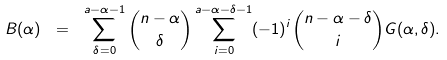<formula> <loc_0><loc_0><loc_500><loc_500>B ( \alpha ) \ = \ \sum _ { \delta = 0 } ^ { a - \alpha - 1 } \binom { n - \alpha } { \delta } \sum _ { i = 0 } ^ { a - \alpha - \delta - 1 } ( - 1 ) ^ { i } \binom { n - \alpha - \delta } { i } G ( \alpha , \delta ) .</formula> 